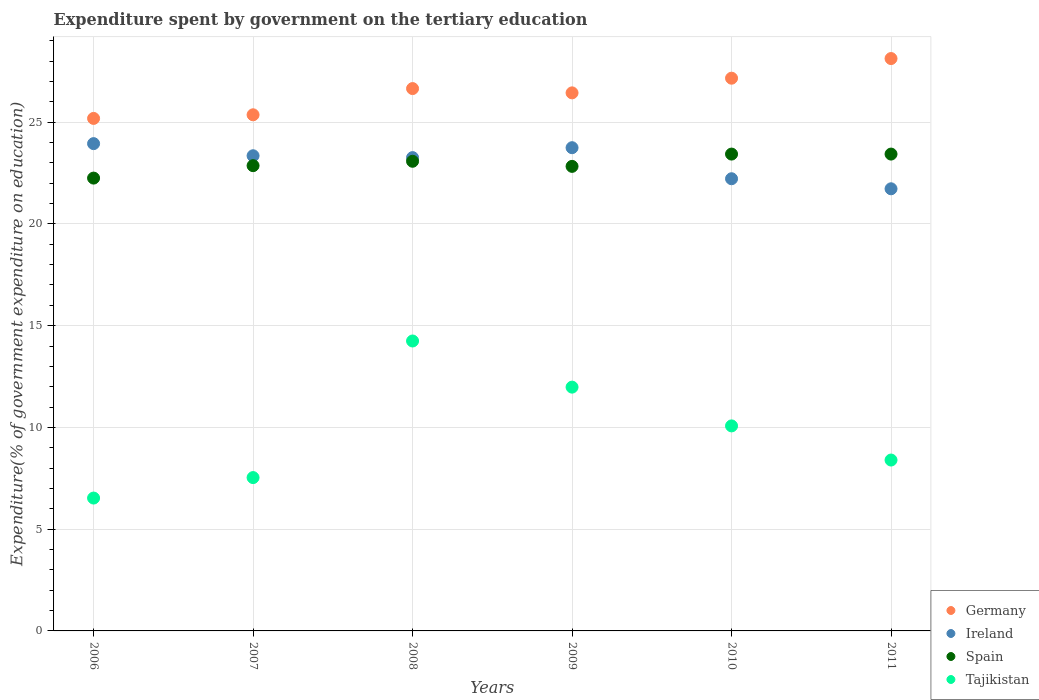How many different coloured dotlines are there?
Provide a succinct answer. 4. What is the expenditure spent by government on the tertiary education in Tajikistan in 2010?
Keep it short and to the point. 10.08. Across all years, what is the maximum expenditure spent by government on the tertiary education in Spain?
Make the answer very short. 23.43. Across all years, what is the minimum expenditure spent by government on the tertiary education in Ireland?
Provide a short and direct response. 21.73. What is the total expenditure spent by government on the tertiary education in Germany in the graph?
Your answer should be very brief. 158.93. What is the difference between the expenditure spent by government on the tertiary education in Spain in 2006 and that in 2010?
Your answer should be compact. -1.18. What is the difference between the expenditure spent by government on the tertiary education in Ireland in 2011 and the expenditure spent by government on the tertiary education in Spain in 2010?
Your answer should be very brief. -1.71. What is the average expenditure spent by government on the tertiary education in Germany per year?
Give a very brief answer. 26.49. In the year 2011, what is the difference between the expenditure spent by government on the tertiary education in Ireland and expenditure spent by government on the tertiary education in Tajikistan?
Give a very brief answer. 13.33. In how many years, is the expenditure spent by government on the tertiary education in Tajikistan greater than 2 %?
Offer a terse response. 6. What is the ratio of the expenditure spent by government on the tertiary education in Germany in 2007 to that in 2010?
Offer a very short reply. 0.93. What is the difference between the highest and the lowest expenditure spent by government on the tertiary education in Tajikistan?
Offer a very short reply. 7.72. Does the expenditure spent by government on the tertiary education in Tajikistan monotonically increase over the years?
Ensure brevity in your answer.  No. Is the expenditure spent by government on the tertiary education in Spain strictly less than the expenditure spent by government on the tertiary education in Tajikistan over the years?
Make the answer very short. No. How many dotlines are there?
Provide a short and direct response. 4. What is the difference between two consecutive major ticks on the Y-axis?
Offer a very short reply. 5. Are the values on the major ticks of Y-axis written in scientific E-notation?
Ensure brevity in your answer.  No. Does the graph contain any zero values?
Your response must be concise. No. Where does the legend appear in the graph?
Provide a succinct answer. Bottom right. How many legend labels are there?
Your answer should be compact. 4. What is the title of the graph?
Keep it short and to the point. Expenditure spent by government on the tertiary education. What is the label or title of the Y-axis?
Your answer should be compact. Expenditure(% of government expenditure on education). What is the Expenditure(% of government expenditure on education) of Germany in 2006?
Provide a succinct answer. 25.19. What is the Expenditure(% of government expenditure on education) of Ireland in 2006?
Your answer should be very brief. 23.95. What is the Expenditure(% of government expenditure on education) in Spain in 2006?
Keep it short and to the point. 22.25. What is the Expenditure(% of government expenditure on education) in Tajikistan in 2006?
Make the answer very short. 6.53. What is the Expenditure(% of government expenditure on education) in Germany in 2007?
Your answer should be compact. 25.36. What is the Expenditure(% of government expenditure on education) in Ireland in 2007?
Offer a terse response. 23.35. What is the Expenditure(% of government expenditure on education) in Spain in 2007?
Make the answer very short. 22.86. What is the Expenditure(% of government expenditure on education) in Tajikistan in 2007?
Ensure brevity in your answer.  7.54. What is the Expenditure(% of government expenditure on education) in Germany in 2008?
Give a very brief answer. 26.65. What is the Expenditure(% of government expenditure on education) of Ireland in 2008?
Offer a terse response. 23.26. What is the Expenditure(% of government expenditure on education) of Spain in 2008?
Offer a very short reply. 23.08. What is the Expenditure(% of government expenditure on education) of Tajikistan in 2008?
Provide a short and direct response. 14.25. What is the Expenditure(% of government expenditure on education) of Germany in 2009?
Your answer should be compact. 26.44. What is the Expenditure(% of government expenditure on education) of Ireland in 2009?
Offer a very short reply. 23.75. What is the Expenditure(% of government expenditure on education) in Spain in 2009?
Provide a succinct answer. 22.83. What is the Expenditure(% of government expenditure on education) of Tajikistan in 2009?
Your answer should be compact. 11.98. What is the Expenditure(% of government expenditure on education) of Germany in 2010?
Make the answer very short. 27.16. What is the Expenditure(% of government expenditure on education) in Ireland in 2010?
Keep it short and to the point. 22.22. What is the Expenditure(% of government expenditure on education) in Spain in 2010?
Your answer should be very brief. 23.43. What is the Expenditure(% of government expenditure on education) of Tajikistan in 2010?
Your answer should be very brief. 10.08. What is the Expenditure(% of government expenditure on education) of Germany in 2011?
Offer a terse response. 28.13. What is the Expenditure(% of government expenditure on education) of Ireland in 2011?
Your answer should be very brief. 21.73. What is the Expenditure(% of government expenditure on education) of Spain in 2011?
Keep it short and to the point. 23.43. What is the Expenditure(% of government expenditure on education) of Tajikistan in 2011?
Provide a succinct answer. 8.4. Across all years, what is the maximum Expenditure(% of government expenditure on education) of Germany?
Ensure brevity in your answer.  28.13. Across all years, what is the maximum Expenditure(% of government expenditure on education) of Ireland?
Your answer should be compact. 23.95. Across all years, what is the maximum Expenditure(% of government expenditure on education) in Spain?
Give a very brief answer. 23.43. Across all years, what is the maximum Expenditure(% of government expenditure on education) in Tajikistan?
Provide a short and direct response. 14.25. Across all years, what is the minimum Expenditure(% of government expenditure on education) of Germany?
Provide a short and direct response. 25.19. Across all years, what is the minimum Expenditure(% of government expenditure on education) in Ireland?
Your answer should be compact. 21.73. Across all years, what is the minimum Expenditure(% of government expenditure on education) of Spain?
Keep it short and to the point. 22.25. Across all years, what is the minimum Expenditure(% of government expenditure on education) of Tajikistan?
Your answer should be compact. 6.53. What is the total Expenditure(% of government expenditure on education) of Germany in the graph?
Keep it short and to the point. 158.93. What is the total Expenditure(% of government expenditure on education) of Ireland in the graph?
Your answer should be compact. 138.25. What is the total Expenditure(% of government expenditure on education) in Spain in the graph?
Your answer should be very brief. 137.89. What is the total Expenditure(% of government expenditure on education) of Tajikistan in the graph?
Your response must be concise. 58.77. What is the difference between the Expenditure(% of government expenditure on education) of Germany in 2006 and that in 2007?
Your answer should be very brief. -0.18. What is the difference between the Expenditure(% of government expenditure on education) in Ireland in 2006 and that in 2007?
Your response must be concise. 0.6. What is the difference between the Expenditure(% of government expenditure on education) of Spain in 2006 and that in 2007?
Provide a succinct answer. -0.61. What is the difference between the Expenditure(% of government expenditure on education) in Tajikistan in 2006 and that in 2007?
Provide a succinct answer. -1.01. What is the difference between the Expenditure(% of government expenditure on education) in Germany in 2006 and that in 2008?
Your answer should be very brief. -1.47. What is the difference between the Expenditure(% of government expenditure on education) of Ireland in 2006 and that in 2008?
Your response must be concise. 0.69. What is the difference between the Expenditure(% of government expenditure on education) in Spain in 2006 and that in 2008?
Give a very brief answer. -0.83. What is the difference between the Expenditure(% of government expenditure on education) in Tajikistan in 2006 and that in 2008?
Your response must be concise. -7.72. What is the difference between the Expenditure(% of government expenditure on education) of Germany in 2006 and that in 2009?
Your answer should be very brief. -1.26. What is the difference between the Expenditure(% of government expenditure on education) in Ireland in 2006 and that in 2009?
Keep it short and to the point. 0.2. What is the difference between the Expenditure(% of government expenditure on education) in Spain in 2006 and that in 2009?
Keep it short and to the point. -0.58. What is the difference between the Expenditure(% of government expenditure on education) in Tajikistan in 2006 and that in 2009?
Offer a terse response. -5.45. What is the difference between the Expenditure(% of government expenditure on education) of Germany in 2006 and that in 2010?
Ensure brevity in your answer.  -1.98. What is the difference between the Expenditure(% of government expenditure on education) of Ireland in 2006 and that in 2010?
Your response must be concise. 1.73. What is the difference between the Expenditure(% of government expenditure on education) in Spain in 2006 and that in 2010?
Ensure brevity in your answer.  -1.18. What is the difference between the Expenditure(% of government expenditure on education) of Tajikistan in 2006 and that in 2010?
Provide a succinct answer. -3.55. What is the difference between the Expenditure(% of government expenditure on education) of Germany in 2006 and that in 2011?
Make the answer very short. -2.94. What is the difference between the Expenditure(% of government expenditure on education) in Ireland in 2006 and that in 2011?
Provide a short and direct response. 2.22. What is the difference between the Expenditure(% of government expenditure on education) of Spain in 2006 and that in 2011?
Provide a succinct answer. -1.18. What is the difference between the Expenditure(% of government expenditure on education) of Tajikistan in 2006 and that in 2011?
Ensure brevity in your answer.  -1.87. What is the difference between the Expenditure(% of government expenditure on education) in Germany in 2007 and that in 2008?
Keep it short and to the point. -1.29. What is the difference between the Expenditure(% of government expenditure on education) in Ireland in 2007 and that in 2008?
Your response must be concise. 0.09. What is the difference between the Expenditure(% of government expenditure on education) in Spain in 2007 and that in 2008?
Your answer should be very brief. -0.22. What is the difference between the Expenditure(% of government expenditure on education) in Tajikistan in 2007 and that in 2008?
Give a very brief answer. -6.71. What is the difference between the Expenditure(% of government expenditure on education) of Germany in 2007 and that in 2009?
Your answer should be compact. -1.08. What is the difference between the Expenditure(% of government expenditure on education) in Ireland in 2007 and that in 2009?
Offer a very short reply. -0.4. What is the difference between the Expenditure(% of government expenditure on education) in Spain in 2007 and that in 2009?
Ensure brevity in your answer.  0.03. What is the difference between the Expenditure(% of government expenditure on education) of Tajikistan in 2007 and that in 2009?
Your answer should be very brief. -4.45. What is the difference between the Expenditure(% of government expenditure on education) in Germany in 2007 and that in 2010?
Provide a short and direct response. -1.8. What is the difference between the Expenditure(% of government expenditure on education) in Ireland in 2007 and that in 2010?
Your response must be concise. 1.13. What is the difference between the Expenditure(% of government expenditure on education) of Spain in 2007 and that in 2010?
Make the answer very short. -0.57. What is the difference between the Expenditure(% of government expenditure on education) in Tajikistan in 2007 and that in 2010?
Provide a succinct answer. -2.54. What is the difference between the Expenditure(% of government expenditure on education) in Germany in 2007 and that in 2011?
Offer a terse response. -2.76. What is the difference between the Expenditure(% of government expenditure on education) of Ireland in 2007 and that in 2011?
Offer a terse response. 1.62. What is the difference between the Expenditure(% of government expenditure on education) of Spain in 2007 and that in 2011?
Ensure brevity in your answer.  -0.57. What is the difference between the Expenditure(% of government expenditure on education) of Tajikistan in 2007 and that in 2011?
Ensure brevity in your answer.  -0.86. What is the difference between the Expenditure(% of government expenditure on education) of Germany in 2008 and that in 2009?
Keep it short and to the point. 0.21. What is the difference between the Expenditure(% of government expenditure on education) in Ireland in 2008 and that in 2009?
Offer a terse response. -0.49. What is the difference between the Expenditure(% of government expenditure on education) of Spain in 2008 and that in 2009?
Ensure brevity in your answer.  0.25. What is the difference between the Expenditure(% of government expenditure on education) of Tajikistan in 2008 and that in 2009?
Your answer should be compact. 2.27. What is the difference between the Expenditure(% of government expenditure on education) in Germany in 2008 and that in 2010?
Offer a very short reply. -0.51. What is the difference between the Expenditure(% of government expenditure on education) of Ireland in 2008 and that in 2010?
Your response must be concise. 1.04. What is the difference between the Expenditure(% of government expenditure on education) of Spain in 2008 and that in 2010?
Ensure brevity in your answer.  -0.35. What is the difference between the Expenditure(% of government expenditure on education) of Tajikistan in 2008 and that in 2010?
Ensure brevity in your answer.  4.17. What is the difference between the Expenditure(% of government expenditure on education) in Germany in 2008 and that in 2011?
Offer a very short reply. -1.48. What is the difference between the Expenditure(% of government expenditure on education) of Ireland in 2008 and that in 2011?
Your answer should be compact. 1.53. What is the difference between the Expenditure(% of government expenditure on education) of Spain in 2008 and that in 2011?
Provide a succinct answer. -0.35. What is the difference between the Expenditure(% of government expenditure on education) of Tajikistan in 2008 and that in 2011?
Provide a succinct answer. 5.85. What is the difference between the Expenditure(% of government expenditure on education) of Germany in 2009 and that in 2010?
Provide a short and direct response. -0.72. What is the difference between the Expenditure(% of government expenditure on education) in Ireland in 2009 and that in 2010?
Your answer should be compact. 1.53. What is the difference between the Expenditure(% of government expenditure on education) in Spain in 2009 and that in 2010?
Keep it short and to the point. -0.6. What is the difference between the Expenditure(% of government expenditure on education) of Tajikistan in 2009 and that in 2010?
Your response must be concise. 1.91. What is the difference between the Expenditure(% of government expenditure on education) in Germany in 2009 and that in 2011?
Make the answer very short. -1.69. What is the difference between the Expenditure(% of government expenditure on education) of Ireland in 2009 and that in 2011?
Keep it short and to the point. 2.02. What is the difference between the Expenditure(% of government expenditure on education) of Spain in 2009 and that in 2011?
Ensure brevity in your answer.  -0.6. What is the difference between the Expenditure(% of government expenditure on education) in Tajikistan in 2009 and that in 2011?
Ensure brevity in your answer.  3.58. What is the difference between the Expenditure(% of government expenditure on education) of Germany in 2010 and that in 2011?
Offer a very short reply. -0.97. What is the difference between the Expenditure(% of government expenditure on education) in Ireland in 2010 and that in 2011?
Make the answer very short. 0.49. What is the difference between the Expenditure(% of government expenditure on education) in Spain in 2010 and that in 2011?
Provide a short and direct response. 0. What is the difference between the Expenditure(% of government expenditure on education) in Tajikistan in 2010 and that in 2011?
Your answer should be very brief. 1.68. What is the difference between the Expenditure(% of government expenditure on education) in Germany in 2006 and the Expenditure(% of government expenditure on education) in Ireland in 2007?
Offer a terse response. 1.83. What is the difference between the Expenditure(% of government expenditure on education) in Germany in 2006 and the Expenditure(% of government expenditure on education) in Spain in 2007?
Make the answer very short. 2.32. What is the difference between the Expenditure(% of government expenditure on education) in Germany in 2006 and the Expenditure(% of government expenditure on education) in Tajikistan in 2007?
Your answer should be compact. 17.65. What is the difference between the Expenditure(% of government expenditure on education) of Ireland in 2006 and the Expenditure(% of government expenditure on education) of Spain in 2007?
Keep it short and to the point. 1.08. What is the difference between the Expenditure(% of government expenditure on education) in Ireland in 2006 and the Expenditure(% of government expenditure on education) in Tajikistan in 2007?
Provide a short and direct response. 16.41. What is the difference between the Expenditure(% of government expenditure on education) in Spain in 2006 and the Expenditure(% of government expenditure on education) in Tajikistan in 2007?
Provide a succinct answer. 14.72. What is the difference between the Expenditure(% of government expenditure on education) in Germany in 2006 and the Expenditure(% of government expenditure on education) in Ireland in 2008?
Make the answer very short. 1.93. What is the difference between the Expenditure(% of government expenditure on education) in Germany in 2006 and the Expenditure(% of government expenditure on education) in Spain in 2008?
Your response must be concise. 2.11. What is the difference between the Expenditure(% of government expenditure on education) in Germany in 2006 and the Expenditure(% of government expenditure on education) in Tajikistan in 2008?
Your answer should be very brief. 10.94. What is the difference between the Expenditure(% of government expenditure on education) in Ireland in 2006 and the Expenditure(% of government expenditure on education) in Spain in 2008?
Ensure brevity in your answer.  0.87. What is the difference between the Expenditure(% of government expenditure on education) in Ireland in 2006 and the Expenditure(% of government expenditure on education) in Tajikistan in 2008?
Your response must be concise. 9.7. What is the difference between the Expenditure(% of government expenditure on education) in Spain in 2006 and the Expenditure(% of government expenditure on education) in Tajikistan in 2008?
Offer a terse response. 8.01. What is the difference between the Expenditure(% of government expenditure on education) in Germany in 2006 and the Expenditure(% of government expenditure on education) in Ireland in 2009?
Provide a short and direct response. 1.44. What is the difference between the Expenditure(% of government expenditure on education) in Germany in 2006 and the Expenditure(% of government expenditure on education) in Spain in 2009?
Provide a short and direct response. 2.36. What is the difference between the Expenditure(% of government expenditure on education) of Germany in 2006 and the Expenditure(% of government expenditure on education) of Tajikistan in 2009?
Offer a very short reply. 13.21. What is the difference between the Expenditure(% of government expenditure on education) in Ireland in 2006 and the Expenditure(% of government expenditure on education) in Spain in 2009?
Offer a terse response. 1.12. What is the difference between the Expenditure(% of government expenditure on education) of Ireland in 2006 and the Expenditure(% of government expenditure on education) of Tajikistan in 2009?
Your answer should be very brief. 11.97. What is the difference between the Expenditure(% of government expenditure on education) in Spain in 2006 and the Expenditure(% of government expenditure on education) in Tajikistan in 2009?
Provide a short and direct response. 10.27. What is the difference between the Expenditure(% of government expenditure on education) of Germany in 2006 and the Expenditure(% of government expenditure on education) of Ireland in 2010?
Provide a succinct answer. 2.96. What is the difference between the Expenditure(% of government expenditure on education) in Germany in 2006 and the Expenditure(% of government expenditure on education) in Spain in 2010?
Give a very brief answer. 1.75. What is the difference between the Expenditure(% of government expenditure on education) of Germany in 2006 and the Expenditure(% of government expenditure on education) of Tajikistan in 2010?
Your answer should be compact. 15.11. What is the difference between the Expenditure(% of government expenditure on education) of Ireland in 2006 and the Expenditure(% of government expenditure on education) of Spain in 2010?
Provide a short and direct response. 0.51. What is the difference between the Expenditure(% of government expenditure on education) in Ireland in 2006 and the Expenditure(% of government expenditure on education) in Tajikistan in 2010?
Your answer should be very brief. 13.87. What is the difference between the Expenditure(% of government expenditure on education) in Spain in 2006 and the Expenditure(% of government expenditure on education) in Tajikistan in 2010?
Give a very brief answer. 12.18. What is the difference between the Expenditure(% of government expenditure on education) in Germany in 2006 and the Expenditure(% of government expenditure on education) in Ireland in 2011?
Ensure brevity in your answer.  3.46. What is the difference between the Expenditure(% of government expenditure on education) of Germany in 2006 and the Expenditure(% of government expenditure on education) of Spain in 2011?
Offer a very short reply. 1.75. What is the difference between the Expenditure(% of government expenditure on education) in Germany in 2006 and the Expenditure(% of government expenditure on education) in Tajikistan in 2011?
Ensure brevity in your answer.  16.79. What is the difference between the Expenditure(% of government expenditure on education) of Ireland in 2006 and the Expenditure(% of government expenditure on education) of Spain in 2011?
Ensure brevity in your answer.  0.51. What is the difference between the Expenditure(% of government expenditure on education) in Ireland in 2006 and the Expenditure(% of government expenditure on education) in Tajikistan in 2011?
Offer a terse response. 15.55. What is the difference between the Expenditure(% of government expenditure on education) of Spain in 2006 and the Expenditure(% of government expenditure on education) of Tajikistan in 2011?
Provide a succinct answer. 13.86. What is the difference between the Expenditure(% of government expenditure on education) in Germany in 2007 and the Expenditure(% of government expenditure on education) in Ireland in 2008?
Offer a very short reply. 2.1. What is the difference between the Expenditure(% of government expenditure on education) of Germany in 2007 and the Expenditure(% of government expenditure on education) of Spain in 2008?
Your response must be concise. 2.28. What is the difference between the Expenditure(% of government expenditure on education) in Germany in 2007 and the Expenditure(% of government expenditure on education) in Tajikistan in 2008?
Keep it short and to the point. 11.12. What is the difference between the Expenditure(% of government expenditure on education) in Ireland in 2007 and the Expenditure(% of government expenditure on education) in Spain in 2008?
Make the answer very short. 0.27. What is the difference between the Expenditure(% of government expenditure on education) in Ireland in 2007 and the Expenditure(% of government expenditure on education) in Tajikistan in 2008?
Provide a succinct answer. 9.1. What is the difference between the Expenditure(% of government expenditure on education) in Spain in 2007 and the Expenditure(% of government expenditure on education) in Tajikistan in 2008?
Offer a terse response. 8.62. What is the difference between the Expenditure(% of government expenditure on education) of Germany in 2007 and the Expenditure(% of government expenditure on education) of Ireland in 2009?
Ensure brevity in your answer.  1.62. What is the difference between the Expenditure(% of government expenditure on education) in Germany in 2007 and the Expenditure(% of government expenditure on education) in Spain in 2009?
Offer a terse response. 2.53. What is the difference between the Expenditure(% of government expenditure on education) in Germany in 2007 and the Expenditure(% of government expenditure on education) in Tajikistan in 2009?
Keep it short and to the point. 13.38. What is the difference between the Expenditure(% of government expenditure on education) in Ireland in 2007 and the Expenditure(% of government expenditure on education) in Spain in 2009?
Keep it short and to the point. 0.52. What is the difference between the Expenditure(% of government expenditure on education) of Ireland in 2007 and the Expenditure(% of government expenditure on education) of Tajikistan in 2009?
Your response must be concise. 11.37. What is the difference between the Expenditure(% of government expenditure on education) of Spain in 2007 and the Expenditure(% of government expenditure on education) of Tajikistan in 2009?
Offer a very short reply. 10.88. What is the difference between the Expenditure(% of government expenditure on education) in Germany in 2007 and the Expenditure(% of government expenditure on education) in Ireland in 2010?
Ensure brevity in your answer.  3.14. What is the difference between the Expenditure(% of government expenditure on education) of Germany in 2007 and the Expenditure(% of government expenditure on education) of Spain in 2010?
Keep it short and to the point. 1.93. What is the difference between the Expenditure(% of government expenditure on education) in Germany in 2007 and the Expenditure(% of government expenditure on education) in Tajikistan in 2010?
Your answer should be very brief. 15.29. What is the difference between the Expenditure(% of government expenditure on education) in Ireland in 2007 and the Expenditure(% of government expenditure on education) in Spain in 2010?
Offer a very short reply. -0.08. What is the difference between the Expenditure(% of government expenditure on education) of Ireland in 2007 and the Expenditure(% of government expenditure on education) of Tajikistan in 2010?
Offer a terse response. 13.28. What is the difference between the Expenditure(% of government expenditure on education) in Spain in 2007 and the Expenditure(% of government expenditure on education) in Tajikistan in 2010?
Provide a short and direct response. 12.79. What is the difference between the Expenditure(% of government expenditure on education) of Germany in 2007 and the Expenditure(% of government expenditure on education) of Ireland in 2011?
Your answer should be very brief. 3.64. What is the difference between the Expenditure(% of government expenditure on education) of Germany in 2007 and the Expenditure(% of government expenditure on education) of Spain in 2011?
Make the answer very short. 1.93. What is the difference between the Expenditure(% of government expenditure on education) in Germany in 2007 and the Expenditure(% of government expenditure on education) in Tajikistan in 2011?
Your answer should be compact. 16.97. What is the difference between the Expenditure(% of government expenditure on education) in Ireland in 2007 and the Expenditure(% of government expenditure on education) in Spain in 2011?
Offer a very short reply. -0.08. What is the difference between the Expenditure(% of government expenditure on education) of Ireland in 2007 and the Expenditure(% of government expenditure on education) of Tajikistan in 2011?
Offer a terse response. 14.95. What is the difference between the Expenditure(% of government expenditure on education) of Spain in 2007 and the Expenditure(% of government expenditure on education) of Tajikistan in 2011?
Keep it short and to the point. 14.47. What is the difference between the Expenditure(% of government expenditure on education) in Germany in 2008 and the Expenditure(% of government expenditure on education) in Ireland in 2009?
Keep it short and to the point. 2.91. What is the difference between the Expenditure(% of government expenditure on education) in Germany in 2008 and the Expenditure(% of government expenditure on education) in Spain in 2009?
Keep it short and to the point. 3.82. What is the difference between the Expenditure(% of government expenditure on education) in Germany in 2008 and the Expenditure(% of government expenditure on education) in Tajikistan in 2009?
Give a very brief answer. 14.67. What is the difference between the Expenditure(% of government expenditure on education) in Ireland in 2008 and the Expenditure(% of government expenditure on education) in Spain in 2009?
Ensure brevity in your answer.  0.43. What is the difference between the Expenditure(% of government expenditure on education) in Ireland in 2008 and the Expenditure(% of government expenditure on education) in Tajikistan in 2009?
Make the answer very short. 11.28. What is the difference between the Expenditure(% of government expenditure on education) in Spain in 2008 and the Expenditure(% of government expenditure on education) in Tajikistan in 2009?
Give a very brief answer. 11.1. What is the difference between the Expenditure(% of government expenditure on education) in Germany in 2008 and the Expenditure(% of government expenditure on education) in Ireland in 2010?
Your answer should be very brief. 4.43. What is the difference between the Expenditure(% of government expenditure on education) of Germany in 2008 and the Expenditure(% of government expenditure on education) of Spain in 2010?
Your answer should be very brief. 3.22. What is the difference between the Expenditure(% of government expenditure on education) in Germany in 2008 and the Expenditure(% of government expenditure on education) in Tajikistan in 2010?
Keep it short and to the point. 16.58. What is the difference between the Expenditure(% of government expenditure on education) of Ireland in 2008 and the Expenditure(% of government expenditure on education) of Spain in 2010?
Provide a short and direct response. -0.17. What is the difference between the Expenditure(% of government expenditure on education) in Ireland in 2008 and the Expenditure(% of government expenditure on education) in Tajikistan in 2010?
Provide a short and direct response. 13.18. What is the difference between the Expenditure(% of government expenditure on education) of Spain in 2008 and the Expenditure(% of government expenditure on education) of Tajikistan in 2010?
Your answer should be compact. 13. What is the difference between the Expenditure(% of government expenditure on education) of Germany in 2008 and the Expenditure(% of government expenditure on education) of Ireland in 2011?
Give a very brief answer. 4.92. What is the difference between the Expenditure(% of government expenditure on education) in Germany in 2008 and the Expenditure(% of government expenditure on education) in Spain in 2011?
Offer a terse response. 3.22. What is the difference between the Expenditure(% of government expenditure on education) of Germany in 2008 and the Expenditure(% of government expenditure on education) of Tajikistan in 2011?
Your response must be concise. 18.25. What is the difference between the Expenditure(% of government expenditure on education) of Ireland in 2008 and the Expenditure(% of government expenditure on education) of Spain in 2011?
Provide a short and direct response. -0.17. What is the difference between the Expenditure(% of government expenditure on education) in Ireland in 2008 and the Expenditure(% of government expenditure on education) in Tajikistan in 2011?
Offer a terse response. 14.86. What is the difference between the Expenditure(% of government expenditure on education) of Spain in 2008 and the Expenditure(% of government expenditure on education) of Tajikistan in 2011?
Make the answer very short. 14.68. What is the difference between the Expenditure(% of government expenditure on education) in Germany in 2009 and the Expenditure(% of government expenditure on education) in Ireland in 2010?
Your answer should be compact. 4.22. What is the difference between the Expenditure(% of government expenditure on education) in Germany in 2009 and the Expenditure(% of government expenditure on education) in Spain in 2010?
Your response must be concise. 3.01. What is the difference between the Expenditure(% of government expenditure on education) of Germany in 2009 and the Expenditure(% of government expenditure on education) of Tajikistan in 2010?
Provide a succinct answer. 16.37. What is the difference between the Expenditure(% of government expenditure on education) of Ireland in 2009 and the Expenditure(% of government expenditure on education) of Spain in 2010?
Offer a very short reply. 0.31. What is the difference between the Expenditure(% of government expenditure on education) of Ireland in 2009 and the Expenditure(% of government expenditure on education) of Tajikistan in 2010?
Ensure brevity in your answer.  13.67. What is the difference between the Expenditure(% of government expenditure on education) of Spain in 2009 and the Expenditure(% of government expenditure on education) of Tajikistan in 2010?
Provide a succinct answer. 12.75. What is the difference between the Expenditure(% of government expenditure on education) in Germany in 2009 and the Expenditure(% of government expenditure on education) in Ireland in 2011?
Make the answer very short. 4.71. What is the difference between the Expenditure(% of government expenditure on education) of Germany in 2009 and the Expenditure(% of government expenditure on education) of Spain in 2011?
Give a very brief answer. 3.01. What is the difference between the Expenditure(% of government expenditure on education) of Germany in 2009 and the Expenditure(% of government expenditure on education) of Tajikistan in 2011?
Provide a succinct answer. 18.04. What is the difference between the Expenditure(% of government expenditure on education) of Ireland in 2009 and the Expenditure(% of government expenditure on education) of Spain in 2011?
Give a very brief answer. 0.31. What is the difference between the Expenditure(% of government expenditure on education) in Ireland in 2009 and the Expenditure(% of government expenditure on education) in Tajikistan in 2011?
Your answer should be very brief. 15.35. What is the difference between the Expenditure(% of government expenditure on education) of Spain in 2009 and the Expenditure(% of government expenditure on education) of Tajikistan in 2011?
Keep it short and to the point. 14.43. What is the difference between the Expenditure(% of government expenditure on education) of Germany in 2010 and the Expenditure(% of government expenditure on education) of Ireland in 2011?
Your response must be concise. 5.43. What is the difference between the Expenditure(% of government expenditure on education) of Germany in 2010 and the Expenditure(% of government expenditure on education) of Spain in 2011?
Offer a very short reply. 3.73. What is the difference between the Expenditure(% of government expenditure on education) in Germany in 2010 and the Expenditure(% of government expenditure on education) in Tajikistan in 2011?
Your response must be concise. 18.76. What is the difference between the Expenditure(% of government expenditure on education) of Ireland in 2010 and the Expenditure(% of government expenditure on education) of Spain in 2011?
Offer a very short reply. -1.21. What is the difference between the Expenditure(% of government expenditure on education) of Ireland in 2010 and the Expenditure(% of government expenditure on education) of Tajikistan in 2011?
Keep it short and to the point. 13.82. What is the difference between the Expenditure(% of government expenditure on education) in Spain in 2010 and the Expenditure(% of government expenditure on education) in Tajikistan in 2011?
Offer a very short reply. 15.04. What is the average Expenditure(% of government expenditure on education) of Germany per year?
Keep it short and to the point. 26.49. What is the average Expenditure(% of government expenditure on education) in Ireland per year?
Give a very brief answer. 23.04. What is the average Expenditure(% of government expenditure on education) of Spain per year?
Ensure brevity in your answer.  22.98. What is the average Expenditure(% of government expenditure on education) of Tajikistan per year?
Offer a terse response. 9.79. In the year 2006, what is the difference between the Expenditure(% of government expenditure on education) in Germany and Expenditure(% of government expenditure on education) in Ireland?
Give a very brief answer. 1.24. In the year 2006, what is the difference between the Expenditure(% of government expenditure on education) in Germany and Expenditure(% of government expenditure on education) in Spain?
Keep it short and to the point. 2.93. In the year 2006, what is the difference between the Expenditure(% of government expenditure on education) of Germany and Expenditure(% of government expenditure on education) of Tajikistan?
Ensure brevity in your answer.  18.66. In the year 2006, what is the difference between the Expenditure(% of government expenditure on education) in Ireland and Expenditure(% of government expenditure on education) in Spain?
Your answer should be very brief. 1.69. In the year 2006, what is the difference between the Expenditure(% of government expenditure on education) in Ireland and Expenditure(% of government expenditure on education) in Tajikistan?
Your answer should be compact. 17.42. In the year 2006, what is the difference between the Expenditure(% of government expenditure on education) in Spain and Expenditure(% of government expenditure on education) in Tajikistan?
Offer a terse response. 15.72. In the year 2007, what is the difference between the Expenditure(% of government expenditure on education) in Germany and Expenditure(% of government expenditure on education) in Ireland?
Keep it short and to the point. 2.01. In the year 2007, what is the difference between the Expenditure(% of government expenditure on education) of Germany and Expenditure(% of government expenditure on education) of Spain?
Your answer should be very brief. 2.5. In the year 2007, what is the difference between the Expenditure(% of government expenditure on education) in Germany and Expenditure(% of government expenditure on education) in Tajikistan?
Offer a very short reply. 17.83. In the year 2007, what is the difference between the Expenditure(% of government expenditure on education) of Ireland and Expenditure(% of government expenditure on education) of Spain?
Offer a terse response. 0.49. In the year 2007, what is the difference between the Expenditure(% of government expenditure on education) in Ireland and Expenditure(% of government expenditure on education) in Tajikistan?
Provide a succinct answer. 15.82. In the year 2007, what is the difference between the Expenditure(% of government expenditure on education) in Spain and Expenditure(% of government expenditure on education) in Tajikistan?
Provide a short and direct response. 15.33. In the year 2008, what is the difference between the Expenditure(% of government expenditure on education) of Germany and Expenditure(% of government expenditure on education) of Ireland?
Give a very brief answer. 3.39. In the year 2008, what is the difference between the Expenditure(% of government expenditure on education) of Germany and Expenditure(% of government expenditure on education) of Spain?
Provide a succinct answer. 3.57. In the year 2008, what is the difference between the Expenditure(% of government expenditure on education) of Germany and Expenditure(% of government expenditure on education) of Tajikistan?
Make the answer very short. 12.4. In the year 2008, what is the difference between the Expenditure(% of government expenditure on education) in Ireland and Expenditure(% of government expenditure on education) in Spain?
Make the answer very short. 0.18. In the year 2008, what is the difference between the Expenditure(% of government expenditure on education) of Ireland and Expenditure(% of government expenditure on education) of Tajikistan?
Keep it short and to the point. 9.01. In the year 2008, what is the difference between the Expenditure(% of government expenditure on education) in Spain and Expenditure(% of government expenditure on education) in Tajikistan?
Your answer should be compact. 8.83. In the year 2009, what is the difference between the Expenditure(% of government expenditure on education) in Germany and Expenditure(% of government expenditure on education) in Ireland?
Keep it short and to the point. 2.69. In the year 2009, what is the difference between the Expenditure(% of government expenditure on education) of Germany and Expenditure(% of government expenditure on education) of Spain?
Offer a very short reply. 3.61. In the year 2009, what is the difference between the Expenditure(% of government expenditure on education) in Germany and Expenditure(% of government expenditure on education) in Tajikistan?
Your answer should be very brief. 14.46. In the year 2009, what is the difference between the Expenditure(% of government expenditure on education) of Ireland and Expenditure(% of government expenditure on education) of Spain?
Provide a succinct answer. 0.92. In the year 2009, what is the difference between the Expenditure(% of government expenditure on education) of Ireland and Expenditure(% of government expenditure on education) of Tajikistan?
Keep it short and to the point. 11.77. In the year 2009, what is the difference between the Expenditure(% of government expenditure on education) in Spain and Expenditure(% of government expenditure on education) in Tajikistan?
Make the answer very short. 10.85. In the year 2010, what is the difference between the Expenditure(% of government expenditure on education) of Germany and Expenditure(% of government expenditure on education) of Ireland?
Ensure brevity in your answer.  4.94. In the year 2010, what is the difference between the Expenditure(% of government expenditure on education) of Germany and Expenditure(% of government expenditure on education) of Spain?
Your response must be concise. 3.73. In the year 2010, what is the difference between the Expenditure(% of government expenditure on education) in Germany and Expenditure(% of government expenditure on education) in Tajikistan?
Provide a short and direct response. 17.09. In the year 2010, what is the difference between the Expenditure(% of government expenditure on education) of Ireland and Expenditure(% of government expenditure on education) of Spain?
Your answer should be very brief. -1.21. In the year 2010, what is the difference between the Expenditure(% of government expenditure on education) in Ireland and Expenditure(% of government expenditure on education) in Tajikistan?
Provide a short and direct response. 12.15. In the year 2010, what is the difference between the Expenditure(% of government expenditure on education) of Spain and Expenditure(% of government expenditure on education) of Tajikistan?
Your response must be concise. 13.36. In the year 2011, what is the difference between the Expenditure(% of government expenditure on education) of Germany and Expenditure(% of government expenditure on education) of Ireland?
Ensure brevity in your answer.  6.4. In the year 2011, what is the difference between the Expenditure(% of government expenditure on education) of Germany and Expenditure(% of government expenditure on education) of Spain?
Provide a short and direct response. 4.69. In the year 2011, what is the difference between the Expenditure(% of government expenditure on education) of Germany and Expenditure(% of government expenditure on education) of Tajikistan?
Offer a terse response. 19.73. In the year 2011, what is the difference between the Expenditure(% of government expenditure on education) of Ireland and Expenditure(% of government expenditure on education) of Spain?
Provide a succinct answer. -1.71. In the year 2011, what is the difference between the Expenditure(% of government expenditure on education) of Ireland and Expenditure(% of government expenditure on education) of Tajikistan?
Your answer should be compact. 13.33. In the year 2011, what is the difference between the Expenditure(% of government expenditure on education) of Spain and Expenditure(% of government expenditure on education) of Tajikistan?
Your response must be concise. 15.04. What is the ratio of the Expenditure(% of government expenditure on education) of Ireland in 2006 to that in 2007?
Ensure brevity in your answer.  1.03. What is the ratio of the Expenditure(% of government expenditure on education) in Spain in 2006 to that in 2007?
Your answer should be very brief. 0.97. What is the ratio of the Expenditure(% of government expenditure on education) in Tajikistan in 2006 to that in 2007?
Offer a terse response. 0.87. What is the ratio of the Expenditure(% of government expenditure on education) in Germany in 2006 to that in 2008?
Make the answer very short. 0.94. What is the ratio of the Expenditure(% of government expenditure on education) of Ireland in 2006 to that in 2008?
Your response must be concise. 1.03. What is the ratio of the Expenditure(% of government expenditure on education) in Spain in 2006 to that in 2008?
Your response must be concise. 0.96. What is the ratio of the Expenditure(% of government expenditure on education) in Tajikistan in 2006 to that in 2008?
Provide a succinct answer. 0.46. What is the ratio of the Expenditure(% of government expenditure on education) of Germany in 2006 to that in 2009?
Your response must be concise. 0.95. What is the ratio of the Expenditure(% of government expenditure on education) of Ireland in 2006 to that in 2009?
Your answer should be compact. 1.01. What is the ratio of the Expenditure(% of government expenditure on education) in Spain in 2006 to that in 2009?
Make the answer very short. 0.97. What is the ratio of the Expenditure(% of government expenditure on education) in Tajikistan in 2006 to that in 2009?
Provide a short and direct response. 0.55. What is the ratio of the Expenditure(% of government expenditure on education) in Germany in 2006 to that in 2010?
Provide a succinct answer. 0.93. What is the ratio of the Expenditure(% of government expenditure on education) of Ireland in 2006 to that in 2010?
Your answer should be very brief. 1.08. What is the ratio of the Expenditure(% of government expenditure on education) of Spain in 2006 to that in 2010?
Make the answer very short. 0.95. What is the ratio of the Expenditure(% of government expenditure on education) in Tajikistan in 2006 to that in 2010?
Offer a very short reply. 0.65. What is the ratio of the Expenditure(% of government expenditure on education) of Germany in 2006 to that in 2011?
Your answer should be compact. 0.9. What is the ratio of the Expenditure(% of government expenditure on education) of Ireland in 2006 to that in 2011?
Your answer should be compact. 1.1. What is the ratio of the Expenditure(% of government expenditure on education) of Spain in 2006 to that in 2011?
Provide a short and direct response. 0.95. What is the ratio of the Expenditure(% of government expenditure on education) of Tajikistan in 2006 to that in 2011?
Your answer should be compact. 0.78. What is the ratio of the Expenditure(% of government expenditure on education) in Germany in 2007 to that in 2008?
Provide a succinct answer. 0.95. What is the ratio of the Expenditure(% of government expenditure on education) in Spain in 2007 to that in 2008?
Provide a succinct answer. 0.99. What is the ratio of the Expenditure(% of government expenditure on education) in Tajikistan in 2007 to that in 2008?
Provide a short and direct response. 0.53. What is the ratio of the Expenditure(% of government expenditure on education) in Germany in 2007 to that in 2009?
Offer a very short reply. 0.96. What is the ratio of the Expenditure(% of government expenditure on education) in Ireland in 2007 to that in 2009?
Your answer should be compact. 0.98. What is the ratio of the Expenditure(% of government expenditure on education) in Tajikistan in 2007 to that in 2009?
Ensure brevity in your answer.  0.63. What is the ratio of the Expenditure(% of government expenditure on education) in Germany in 2007 to that in 2010?
Ensure brevity in your answer.  0.93. What is the ratio of the Expenditure(% of government expenditure on education) of Ireland in 2007 to that in 2010?
Give a very brief answer. 1.05. What is the ratio of the Expenditure(% of government expenditure on education) in Spain in 2007 to that in 2010?
Offer a terse response. 0.98. What is the ratio of the Expenditure(% of government expenditure on education) in Tajikistan in 2007 to that in 2010?
Your answer should be compact. 0.75. What is the ratio of the Expenditure(% of government expenditure on education) in Germany in 2007 to that in 2011?
Your answer should be very brief. 0.9. What is the ratio of the Expenditure(% of government expenditure on education) in Ireland in 2007 to that in 2011?
Provide a succinct answer. 1.07. What is the ratio of the Expenditure(% of government expenditure on education) of Spain in 2007 to that in 2011?
Provide a short and direct response. 0.98. What is the ratio of the Expenditure(% of government expenditure on education) of Tajikistan in 2007 to that in 2011?
Provide a succinct answer. 0.9. What is the ratio of the Expenditure(% of government expenditure on education) in Germany in 2008 to that in 2009?
Ensure brevity in your answer.  1.01. What is the ratio of the Expenditure(% of government expenditure on education) in Ireland in 2008 to that in 2009?
Offer a terse response. 0.98. What is the ratio of the Expenditure(% of government expenditure on education) in Spain in 2008 to that in 2009?
Give a very brief answer. 1.01. What is the ratio of the Expenditure(% of government expenditure on education) in Tajikistan in 2008 to that in 2009?
Offer a very short reply. 1.19. What is the ratio of the Expenditure(% of government expenditure on education) in Germany in 2008 to that in 2010?
Give a very brief answer. 0.98. What is the ratio of the Expenditure(% of government expenditure on education) of Ireland in 2008 to that in 2010?
Offer a very short reply. 1.05. What is the ratio of the Expenditure(% of government expenditure on education) of Spain in 2008 to that in 2010?
Your answer should be compact. 0.98. What is the ratio of the Expenditure(% of government expenditure on education) in Tajikistan in 2008 to that in 2010?
Provide a succinct answer. 1.41. What is the ratio of the Expenditure(% of government expenditure on education) of Germany in 2008 to that in 2011?
Your response must be concise. 0.95. What is the ratio of the Expenditure(% of government expenditure on education) of Ireland in 2008 to that in 2011?
Keep it short and to the point. 1.07. What is the ratio of the Expenditure(% of government expenditure on education) of Spain in 2008 to that in 2011?
Make the answer very short. 0.98. What is the ratio of the Expenditure(% of government expenditure on education) in Tajikistan in 2008 to that in 2011?
Offer a very short reply. 1.7. What is the ratio of the Expenditure(% of government expenditure on education) in Germany in 2009 to that in 2010?
Your answer should be compact. 0.97. What is the ratio of the Expenditure(% of government expenditure on education) in Ireland in 2009 to that in 2010?
Provide a short and direct response. 1.07. What is the ratio of the Expenditure(% of government expenditure on education) in Spain in 2009 to that in 2010?
Provide a succinct answer. 0.97. What is the ratio of the Expenditure(% of government expenditure on education) of Tajikistan in 2009 to that in 2010?
Keep it short and to the point. 1.19. What is the ratio of the Expenditure(% of government expenditure on education) in Germany in 2009 to that in 2011?
Keep it short and to the point. 0.94. What is the ratio of the Expenditure(% of government expenditure on education) of Ireland in 2009 to that in 2011?
Your answer should be compact. 1.09. What is the ratio of the Expenditure(% of government expenditure on education) of Spain in 2009 to that in 2011?
Make the answer very short. 0.97. What is the ratio of the Expenditure(% of government expenditure on education) in Tajikistan in 2009 to that in 2011?
Make the answer very short. 1.43. What is the ratio of the Expenditure(% of government expenditure on education) of Germany in 2010 to that in 2011?
Provide a succinct answer. 0.97. What is the ratio of the Expenditure(% of government expenditure on education) in Ireland in 2010 to that in 2011?
Ensure brevity in your answer.  1.02. What is the ratio of the Expenditure(% of government expenditure on education) in Spain in 2010 to that in 2011?
Provide a succinct answer. 1. What is the ratio of the Expenditure(% of government expenditure on education) in Tajikistan in 2010 to that in 2011?
Keep it short and to the point. 1.2. What is the difference between the highest and the second highest Expenditure(% of government expenditure on education) in Germany?
Ensure brevity in your answer.  0.97. What is the difference between the highest and the second highest Expenditure(% of government expenditure on education) of Ireland?
Offer a very short reply. 0.2. What is the difference between the highest and the second highest Expenditure(% of government expenditure on education) in Tajikistan?
Offer a terse response. 2.27. What is the difference between the highest and the lowest Expenditure(% of government expenditure on education) of Germany?
Make the answer very short. 2.94. What is the difference between the highest and the lowest Expenditure(% of government expenditure on education) in Ireland?
Make the answer very short. 2.22. What is the difference between the highest and the lowest Expenditure(% of government expenditure on education) in Spain?
Your response must be concise. 1.18. What is the difference between the highest and the lowest Expenditure(% of government expenditure on education) of Tajikistan?
Offer a very short reply. 7.72. 